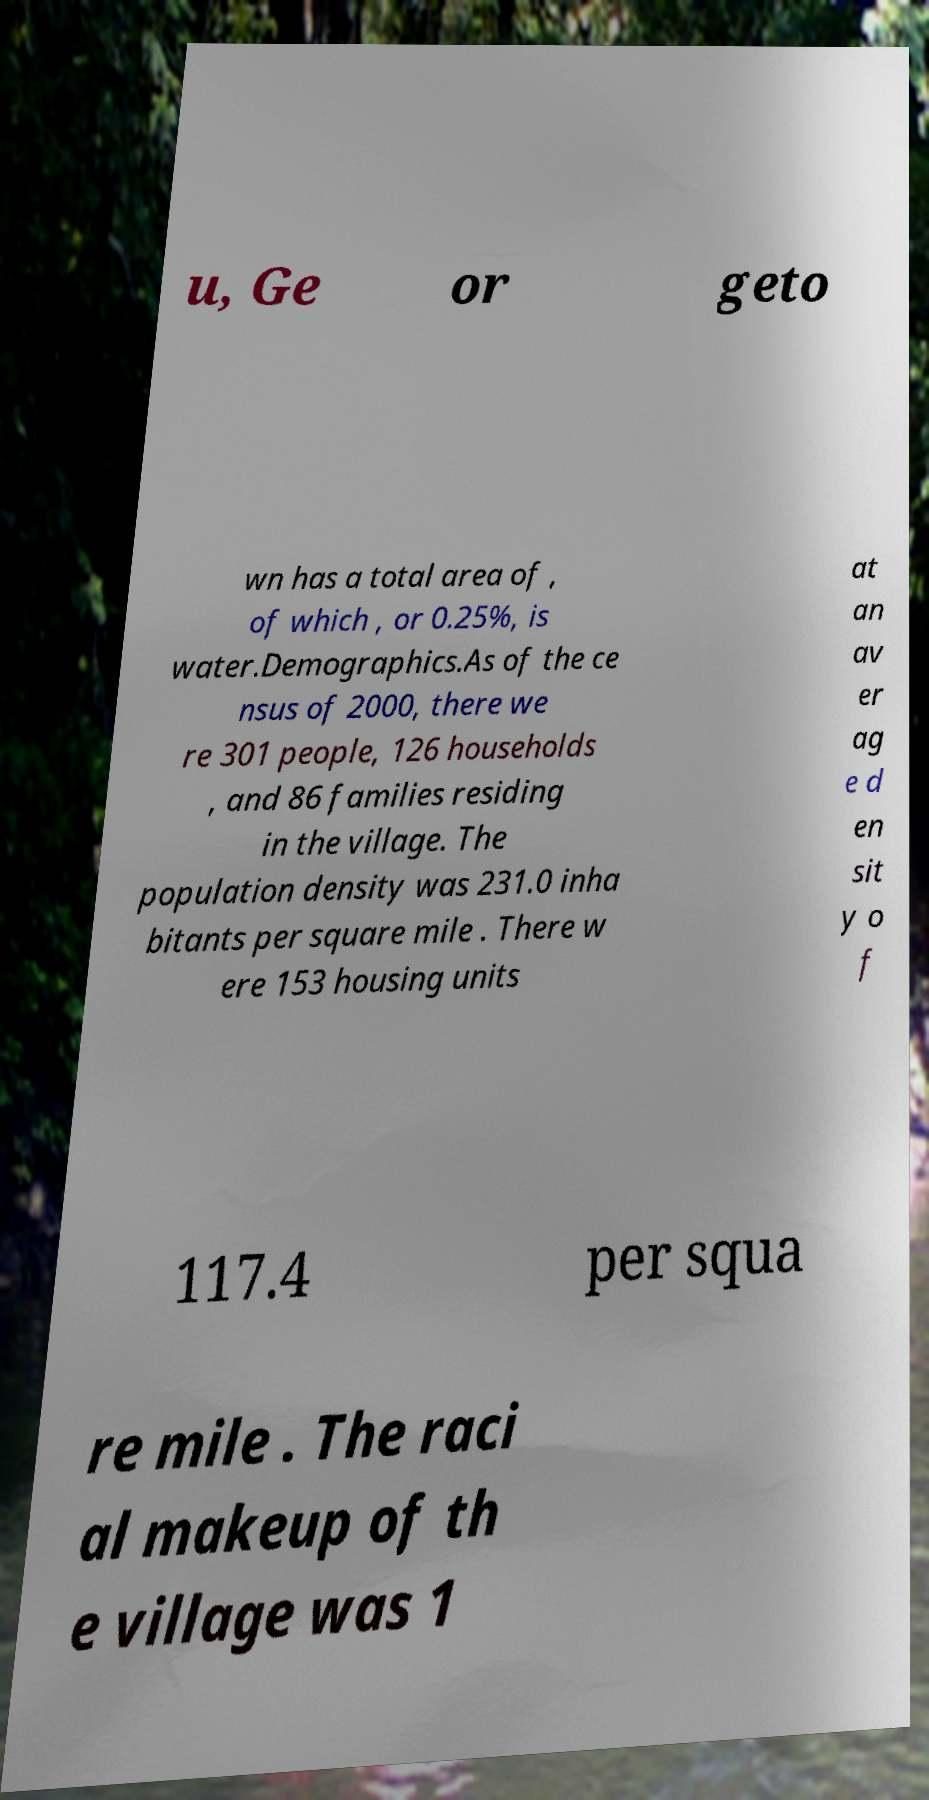Could you extract and type out the text from this image? u, Ge or geto wn has a total area of , of which , or 0.25%, is water.Demographics.As of the ce nsus of 2000, there we re 301 people, 126 households , and 86 families residing in the village. The population density was 231.0 inha bitants per square mile . There w ere 153 housing units at an av er ag e d en sit y o f 117.4 per squa re mile . The raci al makeup of th e village was 1 